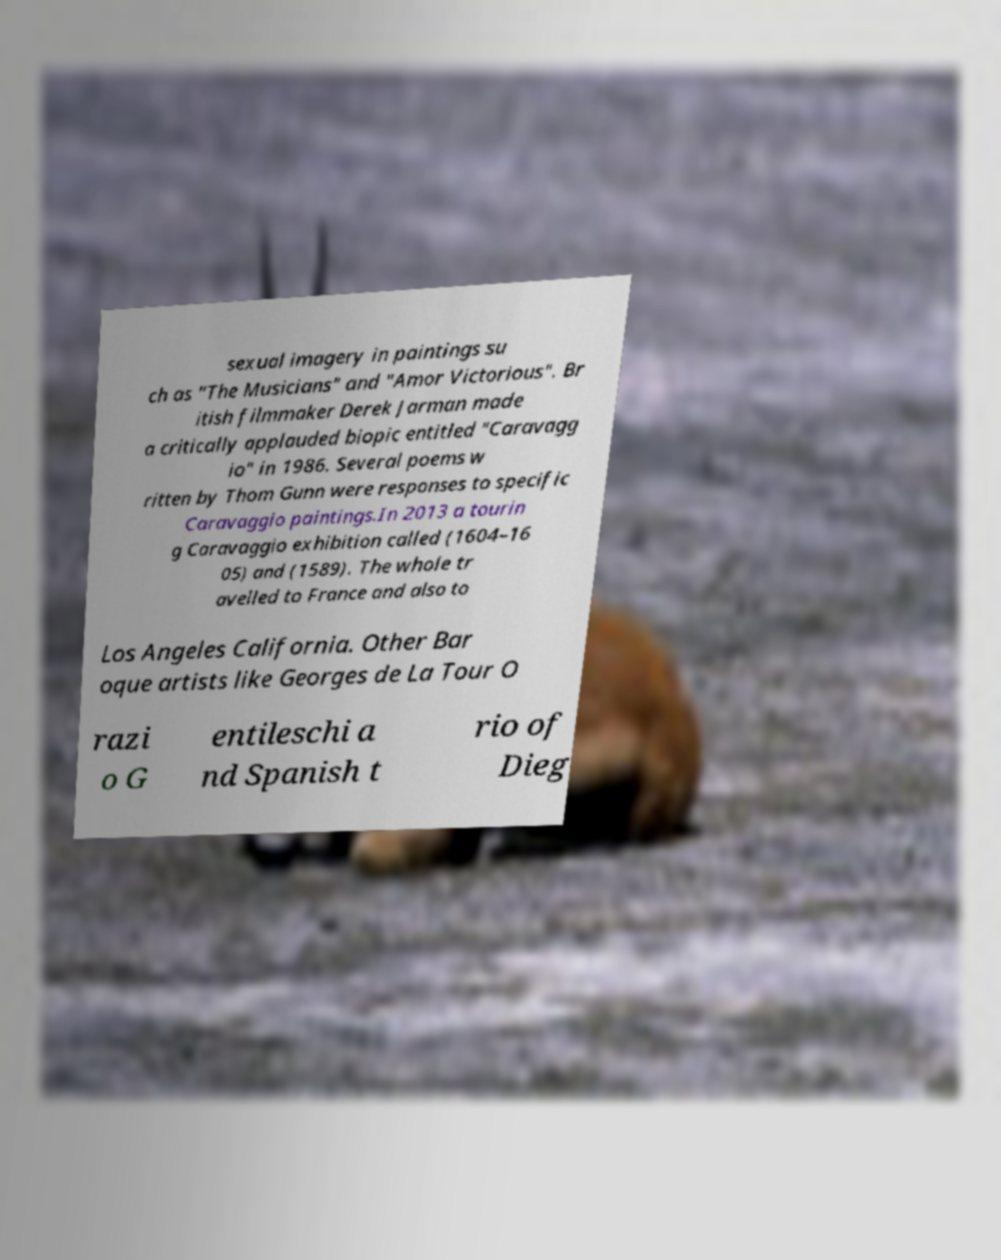What messages or text are displayed in this image? I need them in a readable, typed format. sexual imagery in paintings su ch as "The Musicians" and "Amor Victorious". Br itish filmmaker Derek Jarman made a critically applauded biopic entitled "Caravagg io" in 1986. Several poems w ritten by Thom Gunn were responses to specific Caravaggio paintings.In 2013 a tourin g Caravaggio exhibition called (1604–16 05) and (1589). The whole tr avelled to France and also to Los Angeles California. Other Bar oque artists like Georges de La Tour O razi o G entileschi a nd Spanish t rio of Dieg 